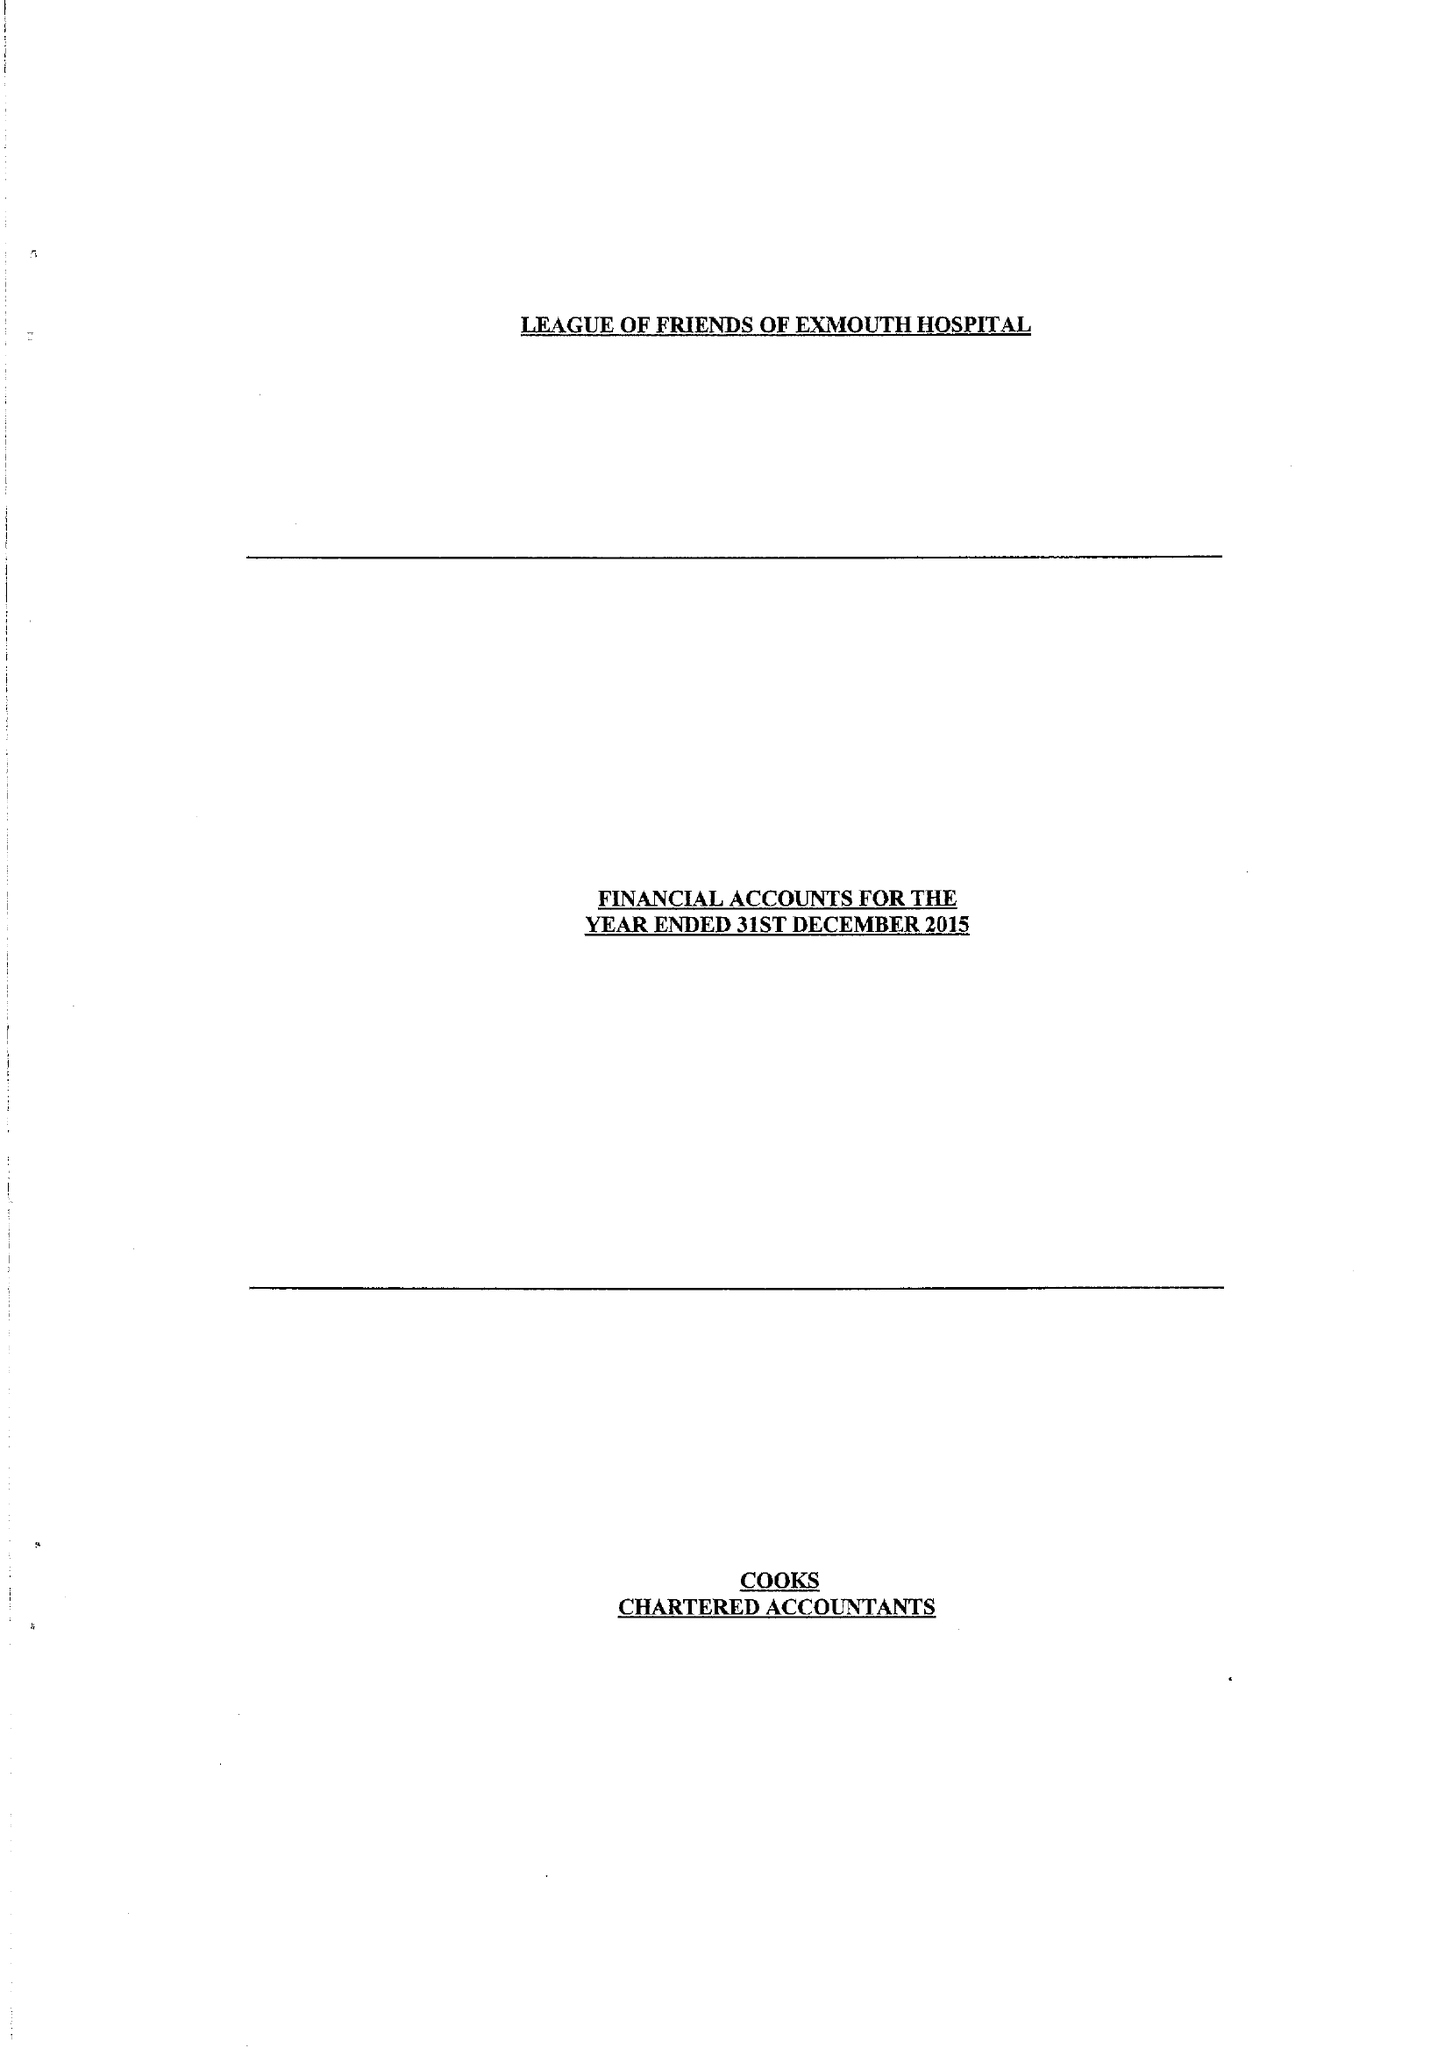What is the value for the address__street_line?
Answer the question using a single word or phrase. CLAREMONT GROVE 